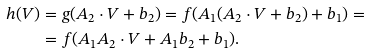<formula> <loc_0><loc_0><loc_500><loc_500>h ( V ) & = g ( A _ { 2 } \cdot V + b _ { 2 } ) = f ( A _ { 1 } ( A _ { 2 } \cdot V + b _ { 2 } ) + b _ { 1 } ) = \\ & = f ( A _ { 1 } A _ { 2 } \cdot V + A _ { 1 } b _ { 2 } + b _ { 1 } ) .</formula> 